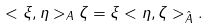Convert formula to latex. <formula><loc_0><loc_0><loc_500><loc_500>< \xi , \eta > _ { A } \zeta = \xi < \eta , \zeta > _ { \hat { A } } .</formula> 